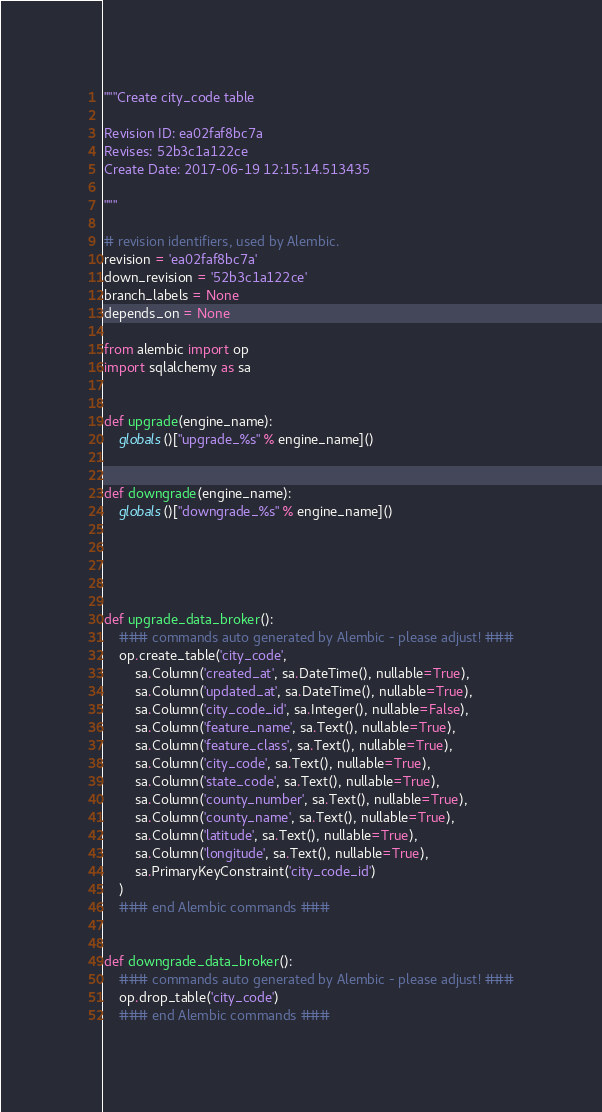Convert code to text. <code><loc_0><loc_0><loc_500><loc_500><_Python_>"""Create city_code table

Revision ID: ea02faf8bc7a
Revises: 52b3c1a122ce
Create Date: 2017-06-19 12:15:14.513435

"""

# revision identifiers, used by Alembic.
revision = 'ea02faf8bc7a'
down_revision = '52b3c1a122ce'
branch_labels = None
depends_on = None

from alembic import op
import sqlalchemy as sa


def upgrade(engine_name):
    globals()["upgrade_%s" % engine_name]()


def downgrade(engine_name):
    globals()["downgrade_%s" % engine_name]()





def upgrade_data_broker():
    ### commands auto generated by Alembic - please adjust! ###
    op.create_table('city_code',
        sa.Column('created_at', sa.DateTime(), nullable=True),
        sa.Column('updated_at', sa.DateTime(), nullable=True),
        sa.Column('city_code_id', sa.Integer(), nullable=False),
        sa.Column('feature_name', sa.Text(), nullable=True),
        sa.Column('feature_class', sa.Text(), nullable=True),
        sa.Column('city_code', sa.Text(), nullable=True),
        sa.Column('state_code', sa.Text(), nullable=True),
        sa.Column('county_number', sa.Text(), nullable=True),
        sa.Column('county_name', sa.Text(), nullable=True),
        sa.Column('latitude', sa.Text(), nullable=True),
        sa.Column('longitude', sa.Text(), nullable=True),
        sa.PrimaryKeyConstraint('city_code_id')
    )
    ### end Alembic commands ###


def downgrade_data_broker():
    ### commands auto generated by Alembic - please adjust! ###
    op.drop_table('city_code')
    ### end Alembic commands ###

</code> 